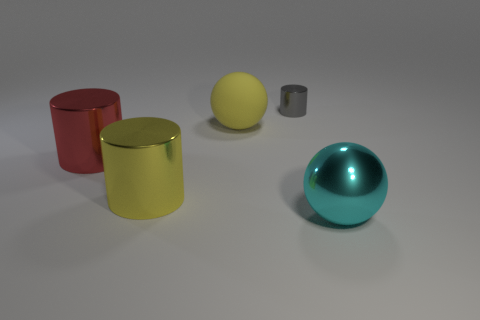Add 4 blue matte cubes. How many objects exist? 9 Subtract all big yellow cylinders. How many cylinders are left? 2 Subtract 1 spheres. How many spheres are left? 1 Subtract all cylinders. How many objects are left? 2 Subtract all cyan spheres. How many spheres are left? 1 Subtract all red cylinders. How many red balls are left? 0 Subtract all rubber balls. Subtract all large cyan shiny objects. How many objects are left? 3 Add 2 tiny cylinders. How many tiny cylinders are left? 3 Add 1 green metal balls. How many green metal balls exist? 1 Subtract 1 red cylinders. How many objects are left? 4 